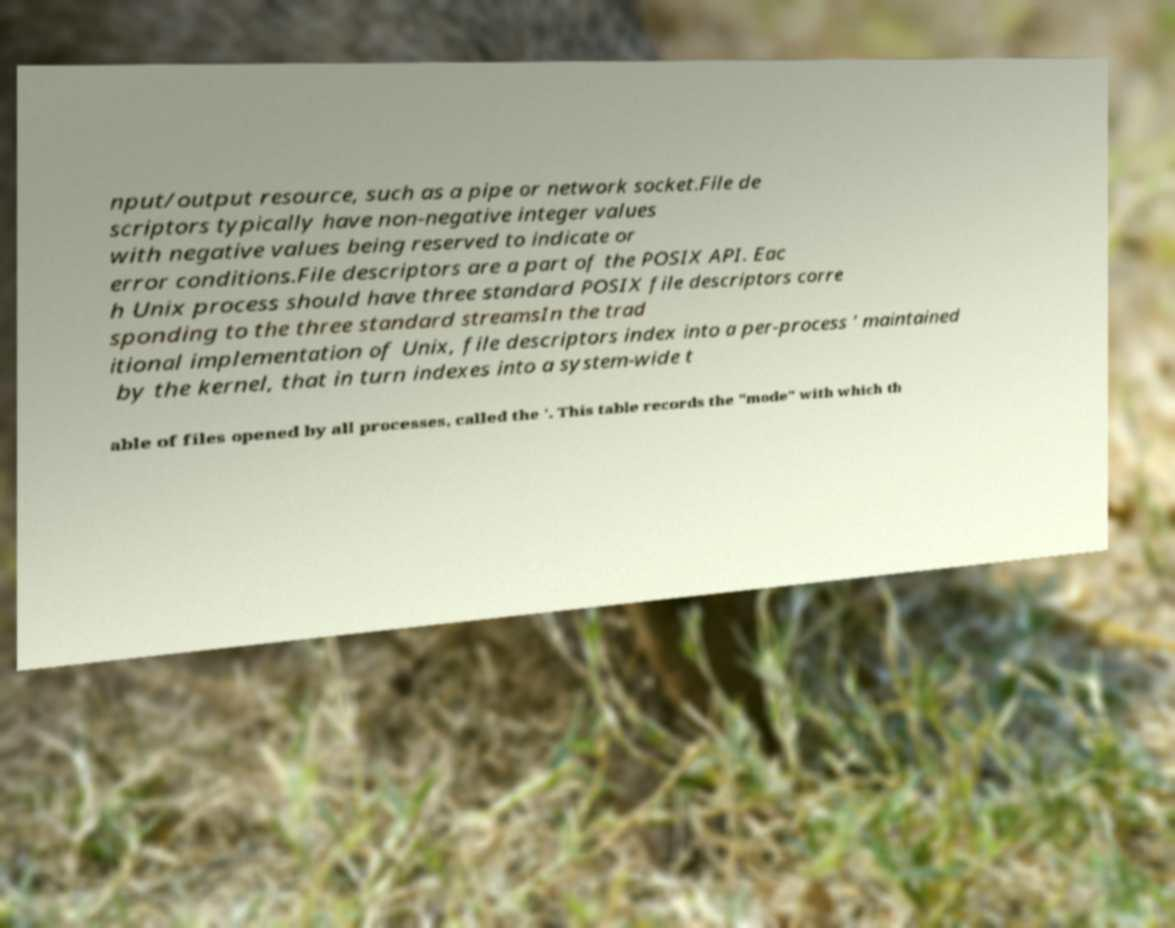Please identify and transcribe the text found in this image. nput/output resource, such as a pipe or network socket.File de scriptors typically have non-negative integer values with negative values being reserved to indicate or error conditions.File descriptors are a part of the POSIX API. Eac h Unix process should have three standard POSIX file descriptors corre sponding to the three standard streamsIn the trad itional implementation of Unix, file descriptors index into a per-process ' maintained by the kernel, that in turn indexes into a system-wide t able of files opened by all processes, called the '. This table records the "mode" with which th 